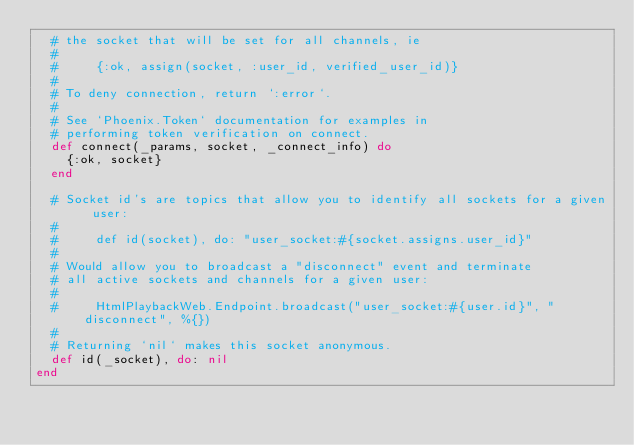<code> <loc_0><loc_0><loc_500><loc_500><_Elixir_>  # the socket that will be set for all channels, ie
  #
  #     {:ok, assign(socket, :user_id, verified_user_id)}
  #
  # To deny connection, return `:error`.
  #
  # See `Phoenix.Token` documentation for examples in
  # performing token verification on connect.
  def connect(_params, socket, _connect_info) do
    {:ok, socket}
  end

  # Socket id's are topics that allow you to identify all sockets for a given user:
  #
  #     def id(socket), do: "user_socket:#{socket.assigns.user_id}"
  #
  # Would allow you to broadcast a "disconnect" event and terminate
  # all active sockets and channels for a given user:
  #
  #     HtmlPlaybackWeb.Endpoint.broadcast("user_socket:#{user.id}", "disconnect", %{})
  #
  # Returning `nil` makes this socket anonymous.
  def id(_socket), do: nil
end
</code> 